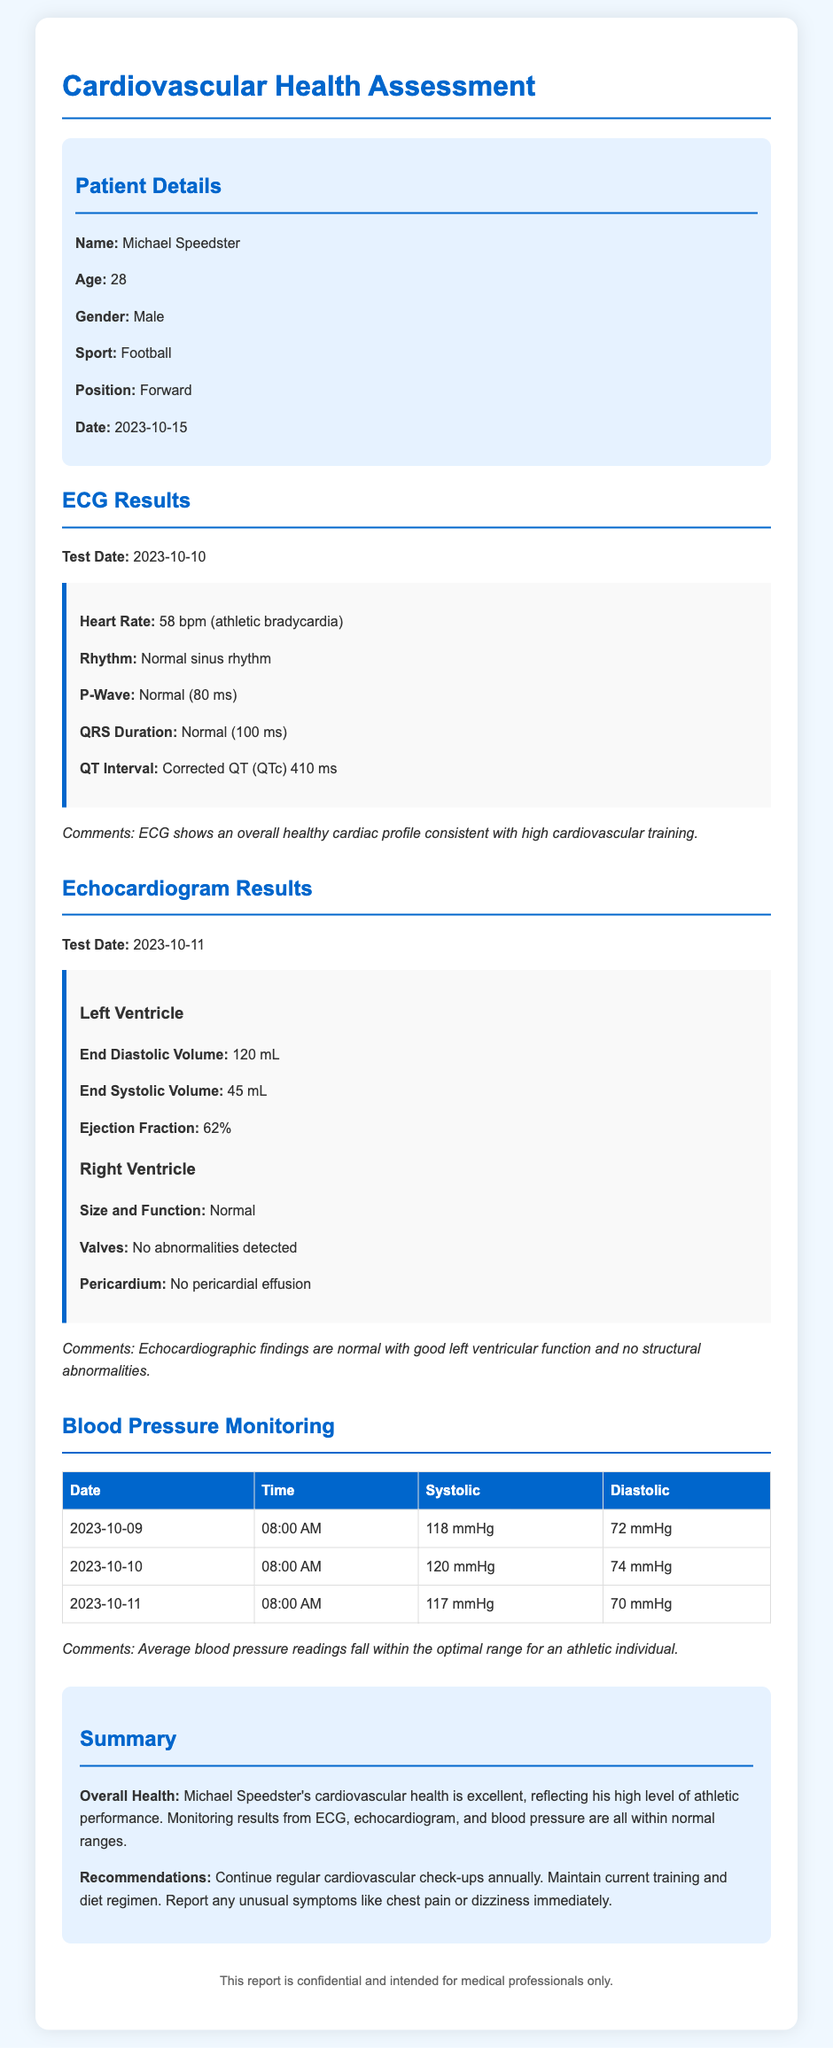What is the patient's name? The patient's name is provided in the patient details section of the document.
Answer: Michael Speedster What is the age of the patient? The age of the patient is mentioned in the document, specifically in the patient details section.
Answer: 28 What were the results for the Heart Rate from the ECG? The heart rate result is a specific measurement mentioned in the ECG results section.
Answer: 58 bpm (athletic bradycardia) What is the Ejection Fraction noted in the Echocardiogram results? The ejection fraction is specified as a key measurement in the echocardiogram results section.
Answer: 62% On what date was the last blood pressure monitoring conducted? The date of the last blood pressure monitoring is listed in the blood pressure section of the document.
Answer: 2023-10-11 What is the average blood pressure reading's comment regarding the athlete? The document provides a comment summarizing the average blood pressure readings.
Answer: Optimal range for an athletic individual What condition was noted for the valves in the Echocardiogram results? The valves condition is explicitly stated in the echocardiogram findings.
Answer: No abnormalities detected What overall health status is described for Michael Speedster? The overall health status is highlighted in the summary section of the document.
Answer: Excellent What is the recommendation for Michael Speedster regarding check-ups? The recommendations include specific advice from the summary section.
Answer: Continue regular cardiovascular check-ups annually 